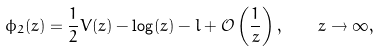<formula> <loc_0><loc_0><loc_500><loc_500>\phi _ { 2 } ( z ) = \frac { 1 } { 2 } V ( z ) - \log ( z ) - l + \mathcal { O } \left ( \frac { 1 } { z } \right ) , \quad z \to \infty ,</formula> 